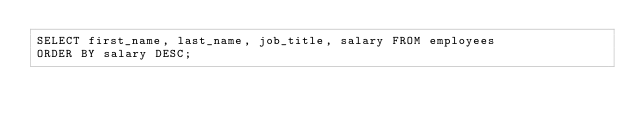<code> <loc_0><loc_0><loc_500><loc_500><_SQL_>SELECT first_name, last_name, job_title, salary FROM employees
ORDER BY salary DESC;</code> 